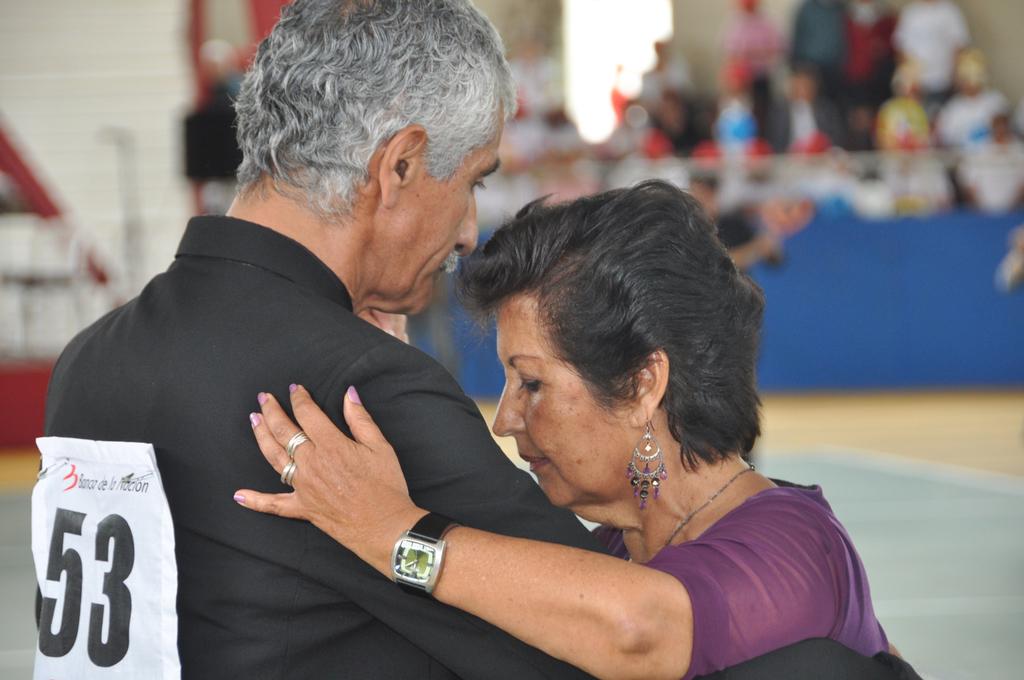What number is the male dancer?
Your response must be concise. 53. 